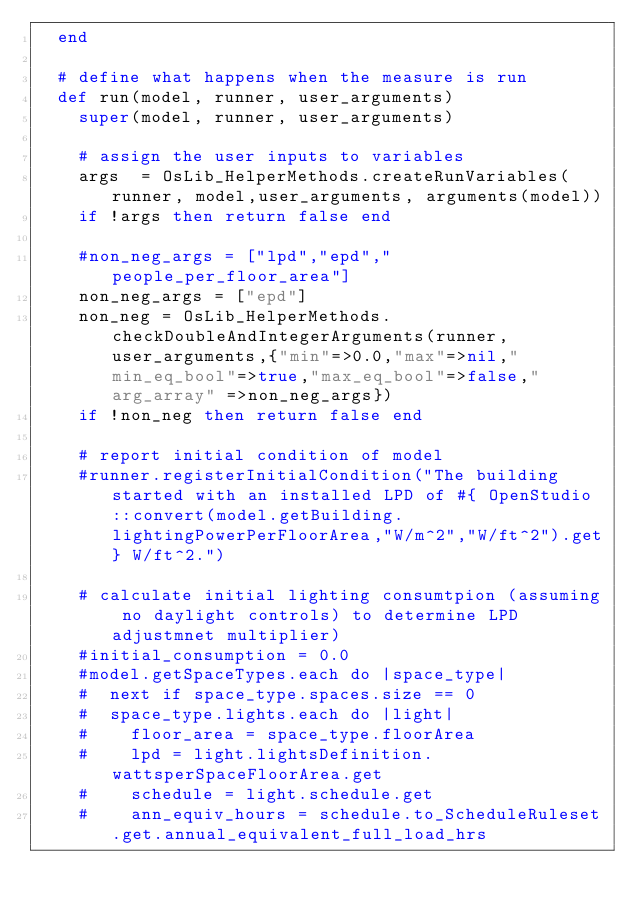<code> <loc_0><loc_0><loc_500><loc_500><_Ruby_>  end

  # define what happens when the measure is run
  def run(model, runner, user_arguments)
    super(model, runner, user_arguments)

    # assign the user inputs to variables
    args  = OsLib_HelperMethods.createRunVariables(runner, model,user_arguments, arguments(model))
    if !args then return false end

    #non_neg_args = ["lpd","epd","people_per_floor_area"]
    non_neg_args = ["epd"]
    non_neg = OsLib_HelperMethods.checkDoubleAndIntegerArguments(runner, user_arguments,{"min"=>0.0,"max"=>nil,"min_eq_bool"=>true,"max_eq_bool"=>false,"arg_array" =>non_neg_args})
    if !non_neg then return false end

    # report initial condition of model
    #runner.registerInitialCondition("The building started with an installed LPD of #{ OpenStudio::convert(model.getBuilding.lightingPowerPerFloorArea,"W/m^2","W/ft^2").get} W/ft^2.")

    # calculate initial lighting consumtpion (assuming no daylight controls) to determine LPD adjustmnet multiplier)
    #initial_consumption = 0.0
    #model.getSpaceTypes.each do |space_type|
    #  next if space_type.spaces.size == 0
    #  space_type.lights.each do |light|
    #    floor_area = space_type.floorArea
    #    lpd = light.lightsDefinition.wattsperSpaceFloorArea.get
    #    schedule = light.schedule.get
    #    ann_equiv_hours = schedule.to_ScheduleRuleset.get.annual_equivalent_full_load_hrs</code> 